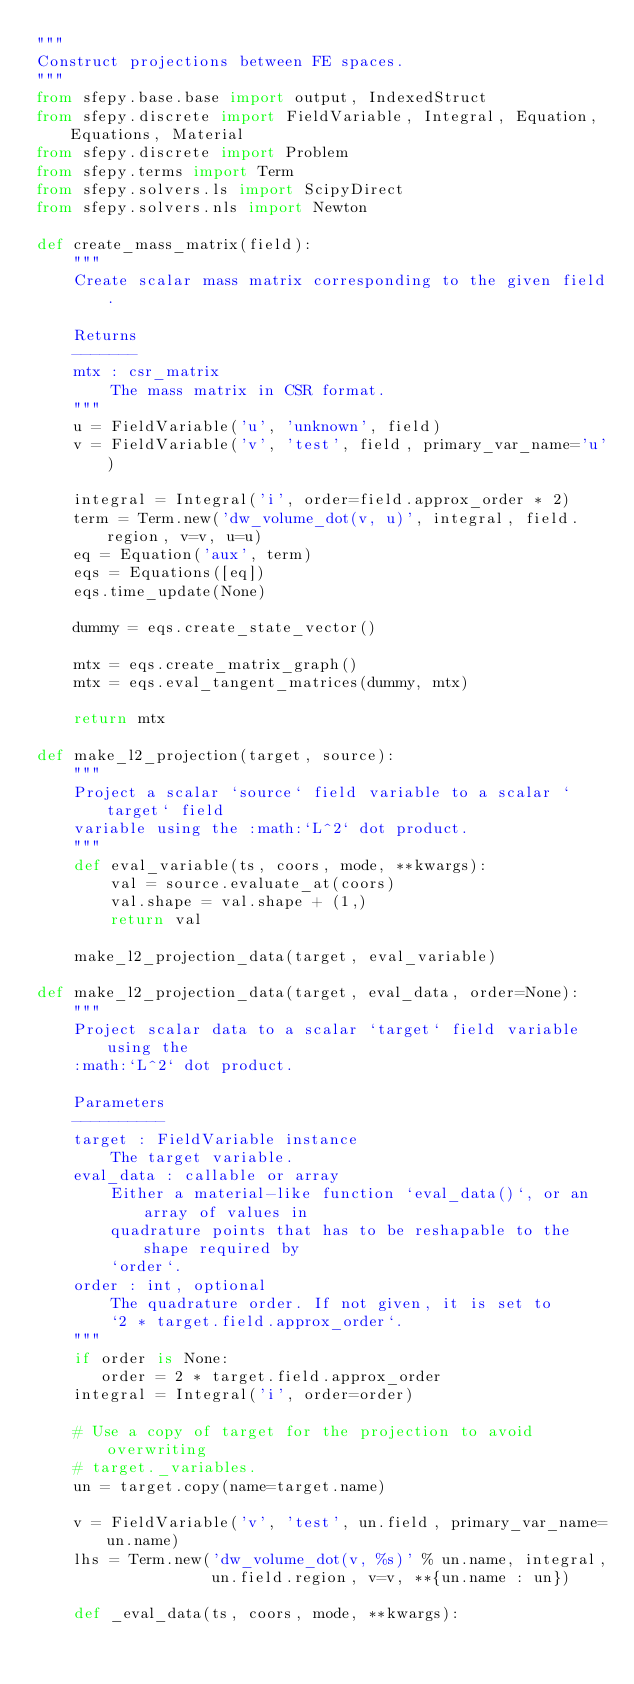<code> <loc_0><loc_0><loc_500><loc_500><_Python_>"""
Construct projections between FE spaces.
"""
from sfepy.base.base import output, IndexedStruct
from sfepy.discrete import FieldVariable, Integral, Equation, Equations, Material
from sfepy.discrete import Problem
from sfepy.terms import Term
from sfepy.solvers.ls import ScipyDirect
from sfepy.solvers.nls import Newton

def create_mass_matrix(field):
    """
    Create scalar mass matrix corresponding to the given field.

    Returns
    -------
    mtx : csr_matrix
        The mass matrix in CSR format.
    """
    u = FieldVariable('u', 'unknown', field)
    v = FieldVariable('v', 'test', field, primary_var_name='u')

    integral = Integral('i', order=field.approx_order * 2)
    term = Term.new('dw_volume_dot(v, u)', integral, field.region, v=v, u=u)
    eq = Equation('aux', term)
    eqs = Equations([eq])
    eqs.time_update(None)

    dummy = eqs.create_state_vector()

    mtx = eqs.create_matrix_graph()
    mtx = eqs.eval_tangent_matrices(dummy, mtx)

    return mtx

def make_l2_projection(target, source):
    """
    Project a scalar `source` field variable to a scalar `target` field
    variable using the :math:`L^2` dot product.
    """
    def eval_variable(ts, coors, mode, **kwargs):
        val = source.evaluate_at(coors)
        val.shape = val.shape + (1,)
        return val

    make_l2_projection_data(target, eval_variable)

def make_l2_projection_data(target, eval_data, order=None):
    """
    Project scalar data to a scalar `target` field variable using the
    :math:`L^2` dot product.

    Parameters
    ----------
    target : FieldVariable instance
        The target variable.
    eval_data : callable or array
        Either a material-like function `eval_data()`, or an array of values in
        quadrature points that has to be reshapable to the shape required by
        `order`.
    order : int, optional
        The quadrature order. If not given, it is set to
        `2 * target.field.approx_order`.
    """
    if order is None:
       order = 2 * target.field.approx_order
    integral = Integral('i', order=order)

    # Use a copy of target for the projection to avoid overwriting
    # target._variables.
    un = target.copy(name=target.name)

    v = FieldVariable('v', 'test', un.field, primary_var_name=un.name)
    lhs = Term.new('dw_volume_dot(v, %s)' % un.name, integral,
                   un.field.region, v=v, **{un.name : un})

    def _eval_data(ts, coors, mode, **kwargs):</code> 